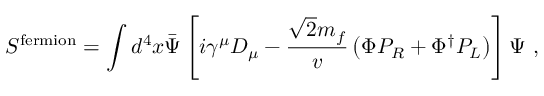Convert formula to latex. <formula><loc_0><loc_0><loc_500><loc_500>S ^ { f e r m i o n } = \int d ^ { 4 } x \bar { \Psi } \left [ i \gamma ^ { \mu } D _ { \mu } - \frac { \sqrt { 2 } m _ { f } } { v } \left ( \Phi P _ { R } + \Phi ^ { \dagger } P _ { L } \right ) \right ] \Psi \ ,</formula> 